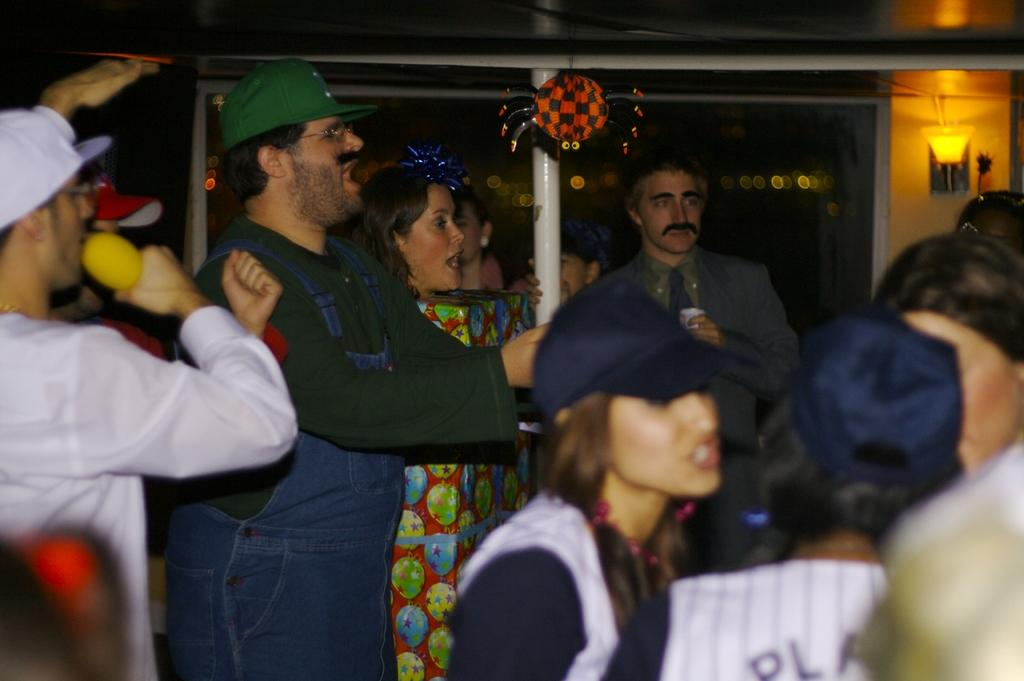What is happening in the image? There are people standing in the image. Can you describe the lighting in the image? There is a light on the right side of the image. What type of pancake is being served on the left side of the image? There is no pancake present in the image; it only shows people standing and a light on the right side. 